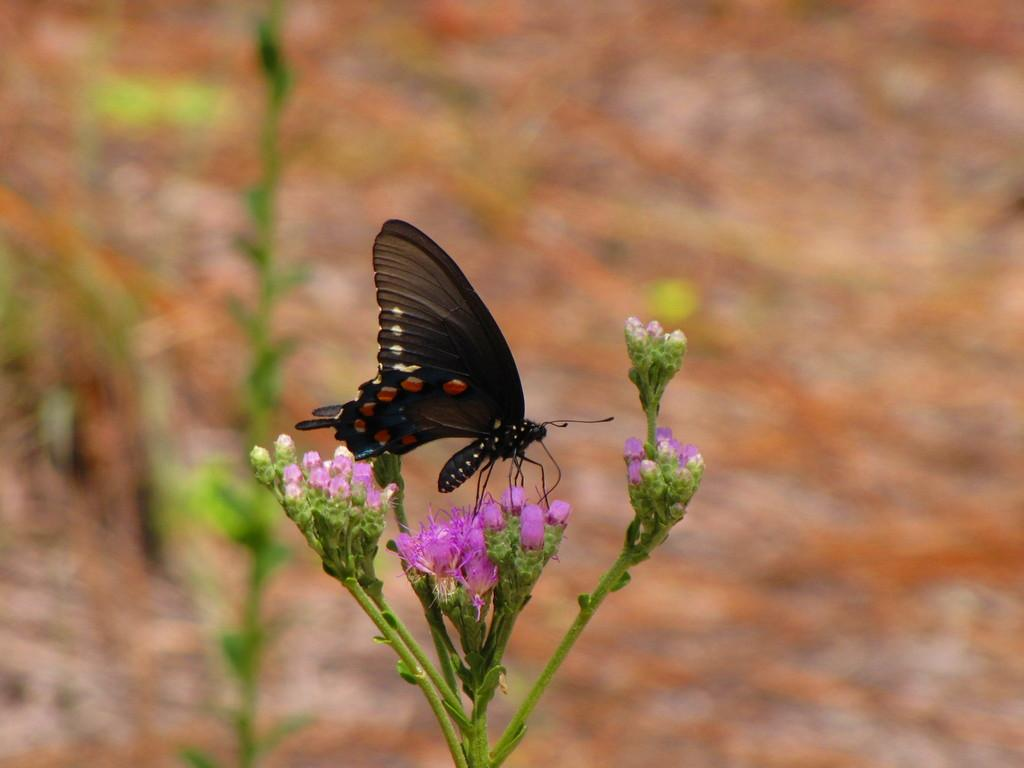What type of plants can be seen in the image? There are flowers in the image. What part of the flowers is visible in the image? There are stems in the image. What other living creature can be seen in the image? There is a butterfly in the image. How would you describe the background of the image? The background of the image is blurred. What type of kitty is playing with the memory in the image? There is no kitty or memory present in the image. How does the butterfly create friction with the flowers in the image? The butterfly does not create friction with the flowers in the image; it is simply flying around them. 